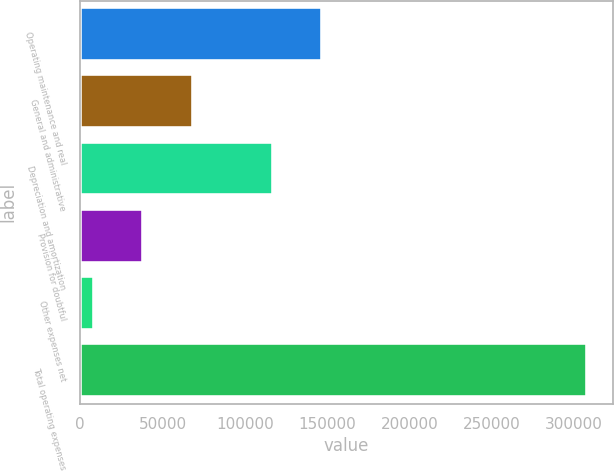Convert chart to OTSL. <chart><loc_0><loc_0><loc_500><loc_500><bar_chart><fcel>Operating maintenance and real<fcel>General and administrative<fcel>Depreciation and amortization<fcel>Provision for doubtful<fcel>Other expenses net<fcel>Total operating expenses<nl><fcel>146898<fcel>68231<fcel>116924<fcel>38257.5<fcel>8284<fcel>308019<nl></chart> 